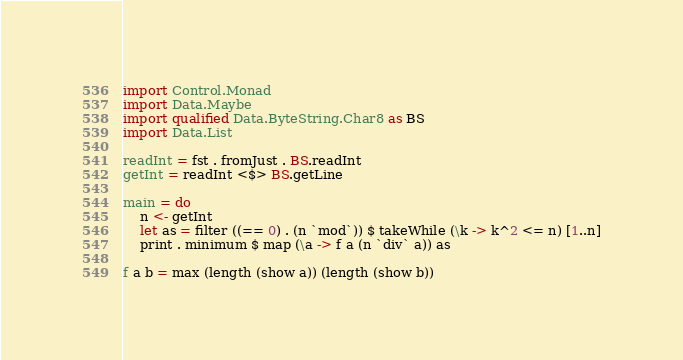<code> <loc_0><loc_0><loc_500><loc_500><_Haskell_>import Control.Monad
import Data.Maybe
import qualified Data.ByteString.Char8 as BS
import Data.List

readInt = fst . fromJust . BS.readInt
getInt = readInt <$> BS.getLine

main = do
    n <- getInt
    let as = filter ((== 0) . (n `mod`)) $ takeWhile (\k -> k^2 <= n) [1..n]
    print . minimum $ map (\a -> f a (n `div` a)) as

f a b = max (length (show a)) (length (show b))</code> 